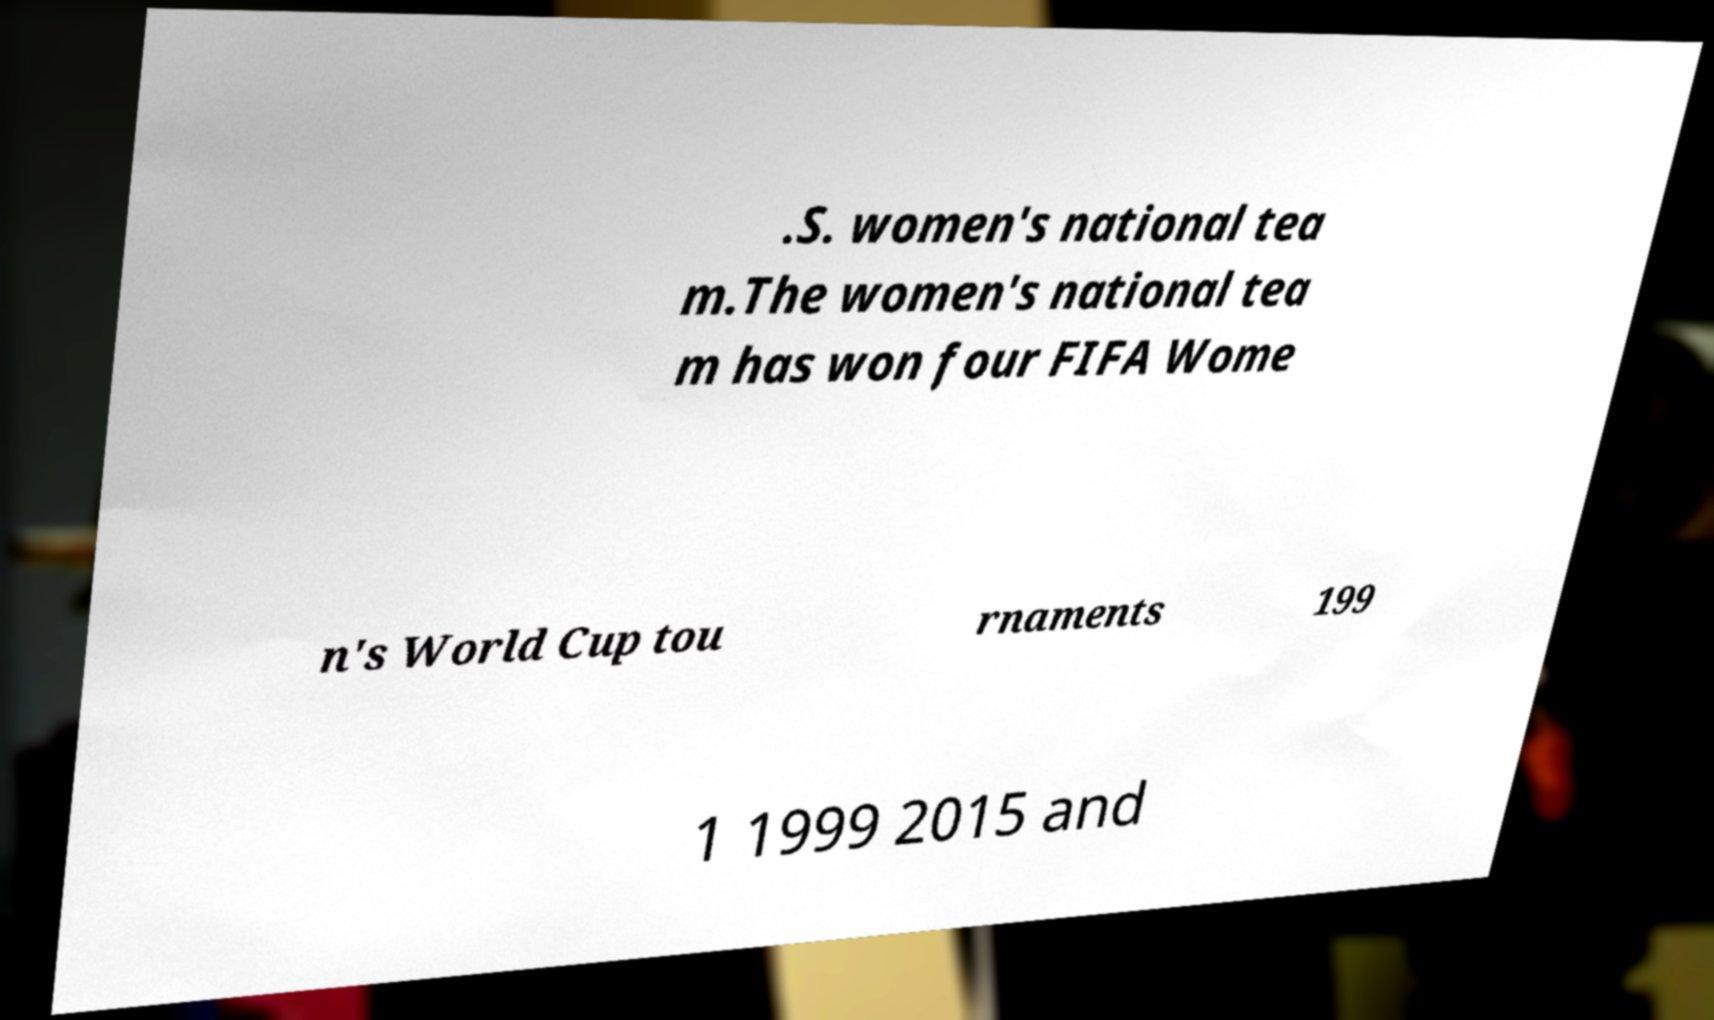I need the written content from this picture converted into text. Can you do that? .S. women's national tea m.The women's national tea m has won four FIFA Wome n's World Cup tou rnaments 199 1 1999 2015 and 